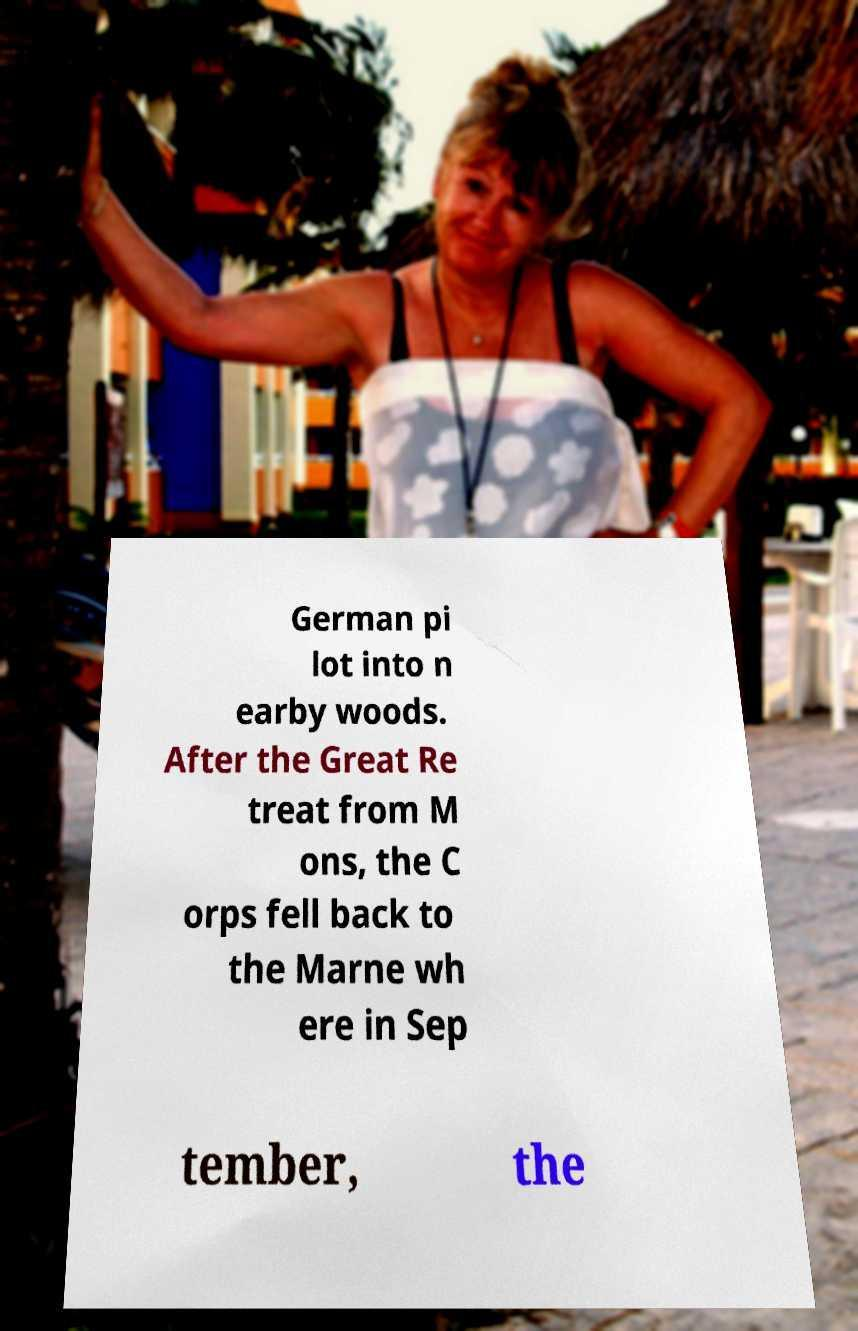Could you extract and type out the text from this image? German pi lot into n earby woods. After the Great Re treat from M ons, the C orps fell back to the Marne wh ere in Sep tember, the 